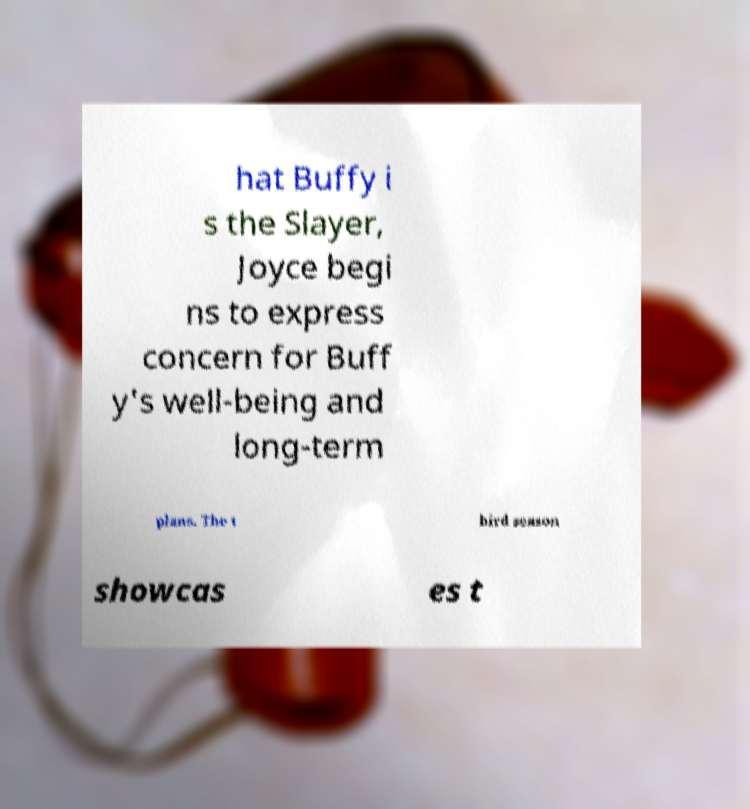I need the written content from this picture converted into text. Can you do that? hat Buffy i s the Slayer, Joyce begi ns to express concern for Buff y's well-being and long-term plans. The t hird season showcas es t 